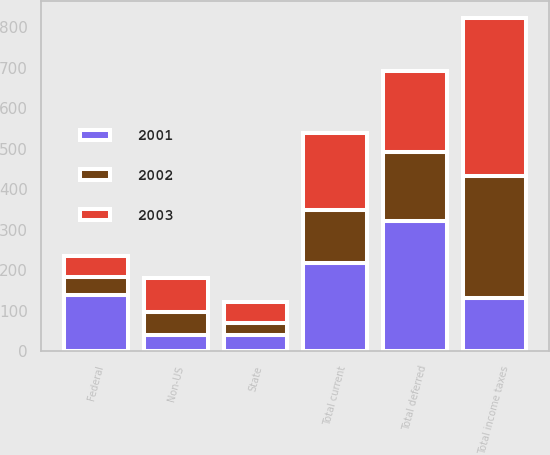<chart> <loc_0><loc_0><loc_500><loc_500><stacked_bar_chart><ecel><fcel>Federal<fcel>State<fcel>Non-US<fcel>Total current<fcel>Total deferred<fcel>Total income taxes<nl><fcel>2003<fcel>53<fcel>53<fcel>84<fcel>190<fcel>200<fcel>390<nl><fcel>2001<fcel>139<fcel>40<fcel>39<fcel>218<fcel>322<fcel>131<nl><fcel>2002<fcel>44<fcel>29<fcel>58<fcel>131<fcel>171<fcel>302<nl></chart> 